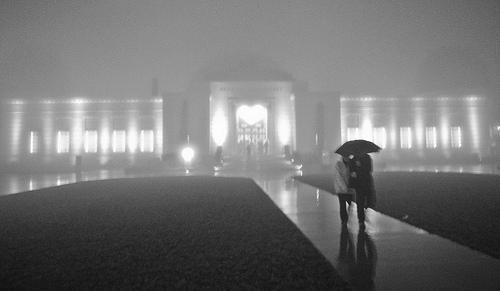How many people are under the umbrella?
Give a very brief answer. 2. How many people walk in the rain?
Give a very brief answer. 2. 